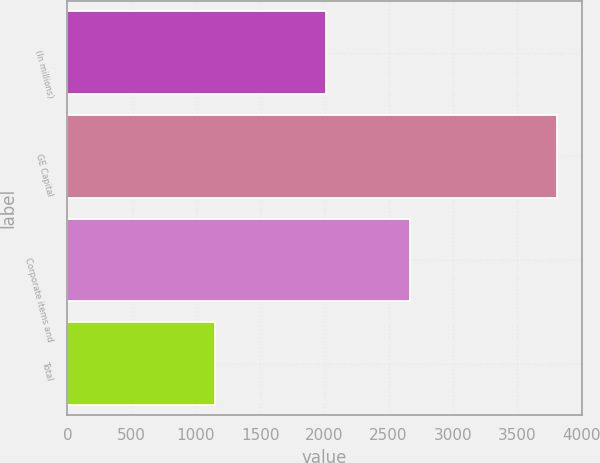Convert chart to OTSL. <chart><loc_0><loc_0><loc_500><loc_500><bar_chart><fcel>(In millions)<fcel>GE Capital<fcel>Corporate items and<fcel>Total<nl><fcel>2009<fcel>3812<fcel>2664<fcel>1148<nl></chart> 